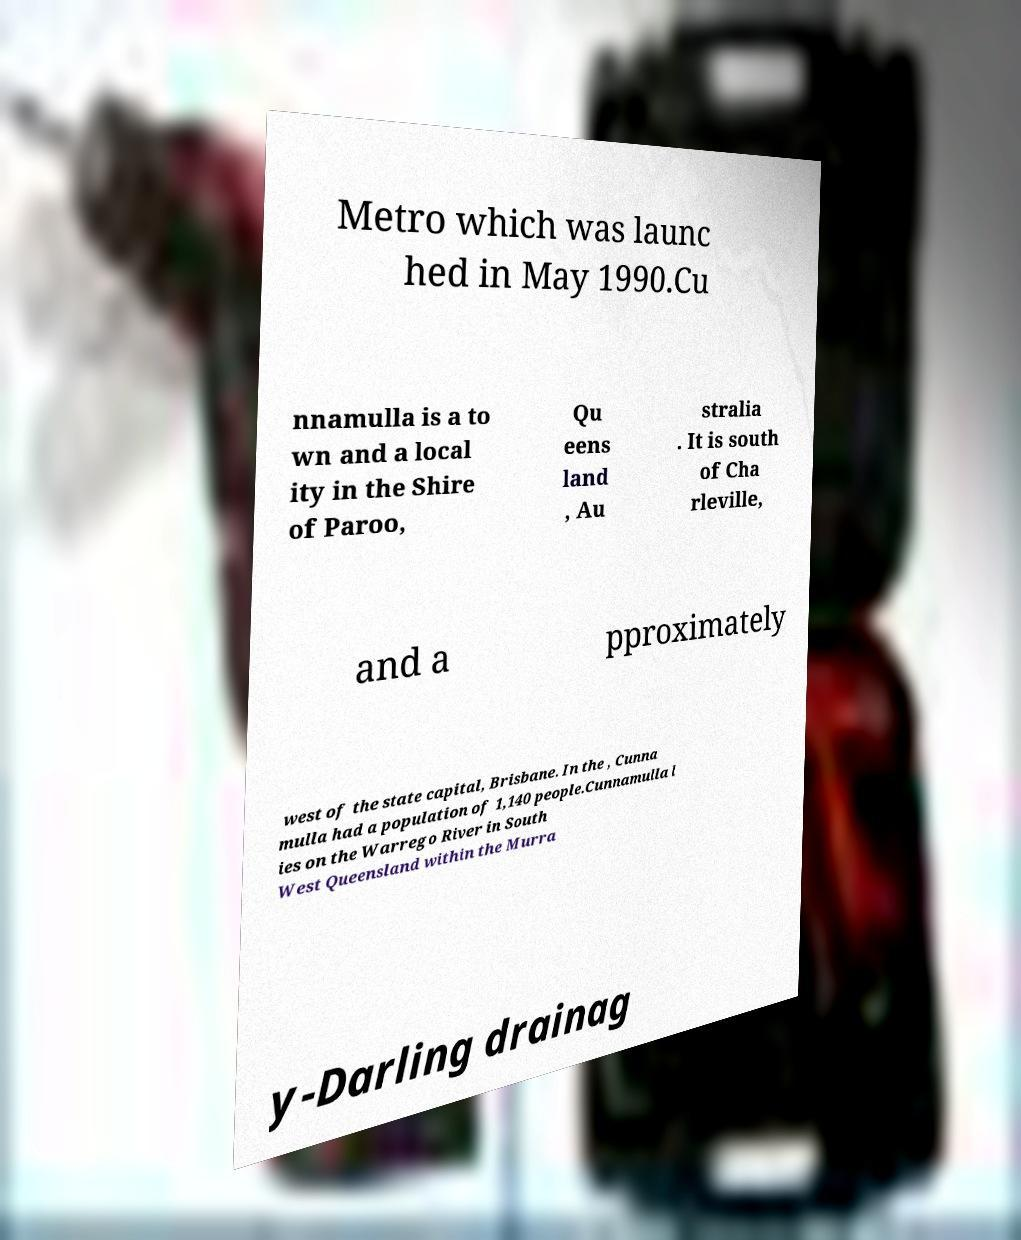Please identify and transcribe the text found in this image. Metro which was launc hed in May 1990.Cu nnamulla is a to wn and a local ity in the Shire of Paroo, Qu eens land , Au stralia . It is south of Cha rleville, and a pproximately west of the state capital, Brisbane. In the , Cunna mulla had a population of 1,140 people.Cunnamulla l ies on the Warrego River in South West Queensland within the Murra y-Darling drainag 